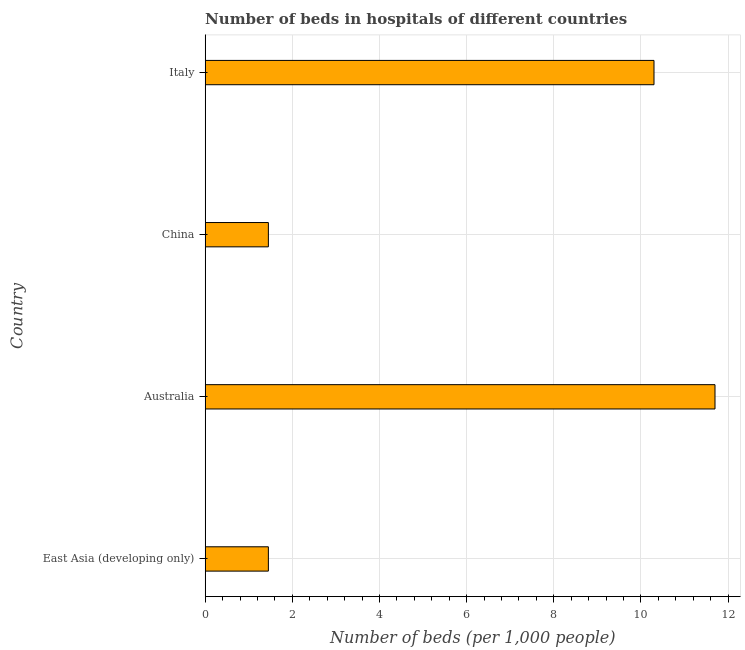Does the graph contain any zero values?
Offer a terse response. No. Does the graph contain grids?
Give a very brief answer. Yes. What is the title of the graph?
Offer a terse response. Number of beds in hospitals of different countries. What is the label or title of the X-axis?
Offer a terse response. Number of beds (per 1,0 people). What is the number of hospital beds in China?
Make the answer very short. 1.45. Across all countries, what is the maximum number of hospital beds?
Your response must be concise. 11.7. Across all countries, what is the minimum number of hospital beds?
Provide a succinct answer. 1.45. In which country was the number of hospital beds minimum?
Ensure brevity in your answer.  East Asia (developing only). What is the sum of the number of hospital beds?
Your response must be concise. 24.9. What is the difference between the number of hospital beds in East Asia (developing only) and Italy?
Your answer should be compact. -8.85. What is the average number of hospital beds per country?
Give a very brief answer. 6.22. What is the median number of hospital beds?
Your answer should be very brief. 5.88. In how many countries, is the number of hospital beds greater than 2.8 %?
Give a very brief answer. 2. What is the ratio of the number of hospital beds in Australia to that in China?
Offer a terse response. 8.07. Is the number of hospital beds in Australia less than that in East Asia (developing only)?
Your response must be concise. No. Is the sum of the number of hospital beds in Australia and Italy greater than the maximum number of hospital beds across all countries?
Provide a succinct answer. Yes. What is the difference between the highest and the lowest number of hospital beds?
Keep it short and to the point. 10.25. In how many countries, is the number of hospital beds greater than the average number of hospital beds taken over all countries?
Keep it short and to the point. 2. What is the difference between two consecutive major ticks on the X-axis?
Offer a very short reply. 2. Are the values on the major ticks of X-axis written in scientific E-notation?
Keep it short and to the point. No. What is the Number of beds (per 1,000 people) of East Asia (developing only)?
Your response must be concise. 1.45. What is the Number of beds (per 1,000 people) in Australia?
Your answer should be compact. 11.7. What is the Number of beds (per 1,000 people) of China?
Your response must be concise. 1.45. What is the Number of beds (per 1,000 people) in Italy?
Give a very brief answer. 10.3. What is the difference between the Number of beds (per 1,000 people) in East Asia (developing only) and Australia?
Offer a very short reply. -10.25. What is the difference between the Number of beds (per 1,000 people) in East Asia (developing only) and China?
Your response must be concise. 0. What is the difference between the Number of beds (per 1,000 people) in East Asia (developing only) and Italy?
Your answer should be very brief. -8.85. What is the difference between the Number of beds (per 1,000 people) in Australia and China?
Give a very brief answer. 10.25. What is the difference between the Number of beds (per 1,000 people) in Australia and Italy?
Ensure brevity in your answer.  1.4. What is the difference between the Number of beds (per 1,000 people) in China and Italy?
Keep it short and to the point. -8.85. What is the ratio of the Number of beds (per 1,000 people) in East Asia (developing only) to that in Australia?
Keep it short and to the point. 0.12. What is the ratio of the Number of beds (per 1,000 people) in East Asia (developing only) to that in China?
Your answer should be compact. 1. What is the ratio of the Number of beds (per 1,000 people) in East Asia (developing only) to that in Italy?
Give a very brief answer. 0.14. What is the ratio of the Number of beds (per 1,000 people) in Australia to that in China?
Ensure brevity in your answer.  8.07. What is the ratio of the Number of beds (per 1,000 people) in Australia to that in Italy?
Ensure brevity in your answer.  1.14. What is the ratio of the Number of beds (per 1,000 people) in China to that in Italy?
Offer a very short reply. 0.14. 